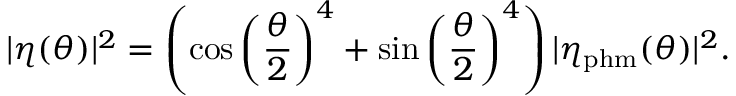<formula> <loc_0><loc_0><loc_500><loc_500>| \eta ( \theta ) | ^ { 2 } = \left ( \cos \left ( \frac { \theta } { 2 } \right ) ^ { 4 } + \sin \left ( \frac { \theta } { 2 } \right ) ^ { 4 } \right ) | \eta _ { p h m } ( \theta ) | ^ { 2 } .</formula> 